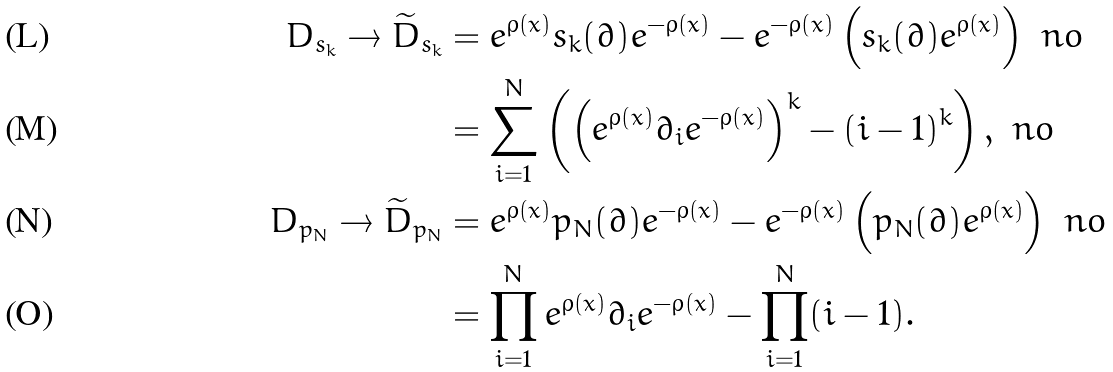<formula> <loc_0><loc_0><loc_500><loc_500>D _ { s _ { k } } \to { \widetilde { D } } _ { s _ { k } } & = e ^ { \rho ( x ) } s _ { k } ( \partial ) e ^ { - \rho ( x ) } - e ^ { - \rho ( x ) } \left ( s _ { k } ( \partial ) e ^ { \rho ( x ) } \right ) \ n o \\ & = \sum _ { i = 1 } ^ { N } \left ( \left ( e ^ { \rho ( x ) } \partial _ { i } e ^ { - \rho ( x ) } \right ) ^ { k } - ( i - 1 ) ^ { k } \right ) , \ n o \\ D _ { p _ { N } } \to { \widetilde { D } } _ { p _ { N } } & = e ^ { \rho ( x ) } p _ { N } ( \partial ) e ^ { - \rho ( x ) } - e ^ { - \rho ( x ) } \left ( p _ { N } ( \partial ) e ^ { \rho ( x ) } \right ) \ n o \\ & = \prod _ { i = 1 } ^ { N } e ^ { \rho ( x ) } \partial _ { i } e ^ { - \rho ( x ) } - \prod _ { i = 1 } ^ { N } ( i - 1 ) .</formula> 